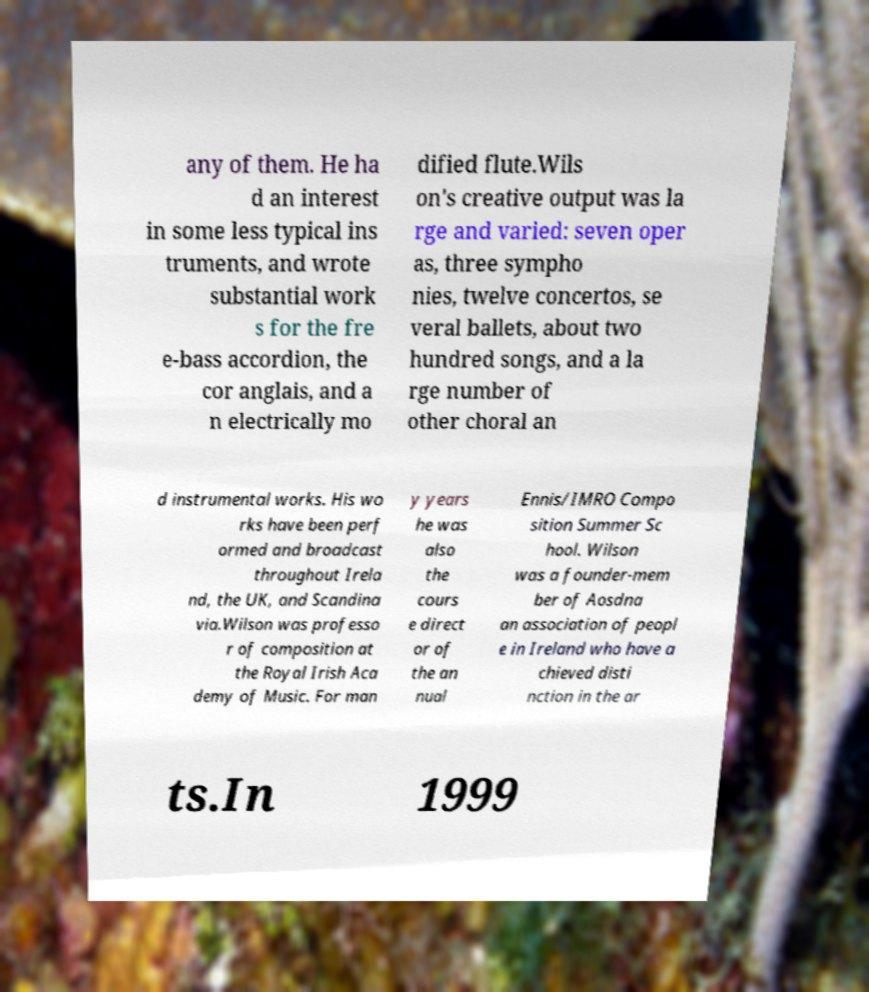Please identify and transcribe the text found in this image. any of them. He ha d an interest in some less typical ins truments, and wrote substantial work s for the fre e-bass accordion, the cor anglais, and a n electrically mo dified flute.Wils on's creative output was la rge and varied: seven oper as, three sympho nies, twelve concertos, se veral ballets, about two hundred songs, and a la rge number of other choral an d instrumental works. His wo rks have been perf ormed and broadcast throughout Irela nd, the UK, and Scandina via.Wilson was professo r of composition at the Royal Irish Aca demy of Music. For man y years he was also the cours e direct or of the an nual Ennis/IMRO Compo sition Summer Sc hool. Wilson was a founder-mem ber of Aosdna an association of peopl e in Ireland who have a chieved disti nction in the ar ts.In 1999 